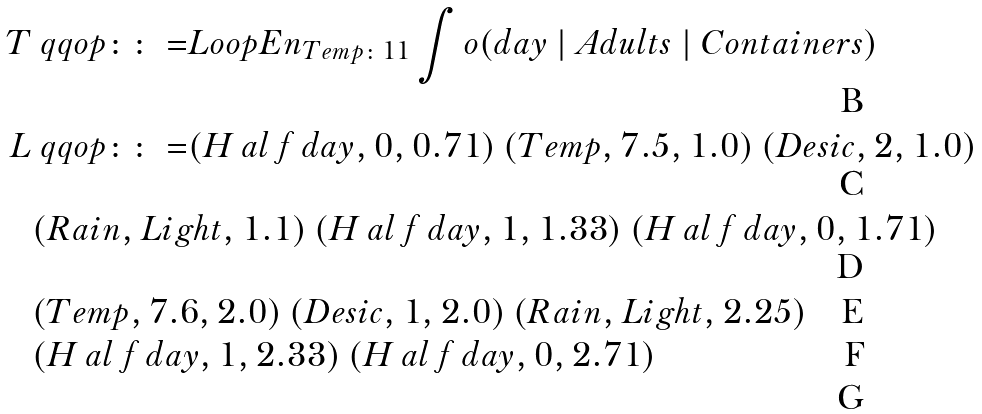<formula> <loc_0><loc_0><loc_500><loc_500>T & \ q q o p { \colon \colon = } L o o p { E n } _ { T e m p \colon 1 1 } \int o ( d a y \ | \ A d u l t s \ | \ C o n t a i n e r s ) \\ L & \ q q o p { \colon \colon = } ( H \, a l \, f \, d a y , 0 , 0 . 7 1 ) \ ( T e m p , 7 . 5 , 1 . 0 ) \ ( D e s i c , 2 , 1 . 0 ) \\ & ( R a i n , L i g h t , 1 . 1 ) \ ( H \, a l \, f \, d a y , 1 , 1 . 3 3 ) \ ( H \, a l \, f \, d a y , 0 , 1 . 7 1 ) \\ & ( T e m p , 7 . 6 , 2 . 0 ) \ ( D e s i c , 1 , 2 . 0 ) \ ( R a i n , L i g h t , 2 . 2 5 ) \\ & ( H \, a l \, f \, d a y , 1 , 2 . 3 3 ) \ ( H \, a l \, f \, d a y , 0 , 2 . 7 1 ) \\</formula> 